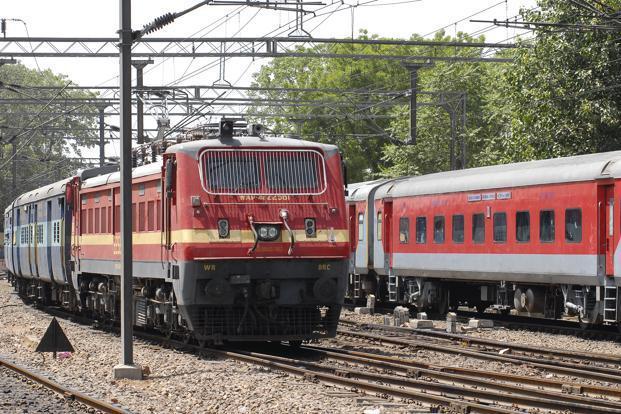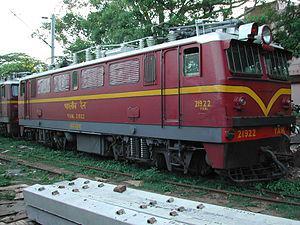The first image is the image on the left, the second image is the image on the right. Given the left and right images, does the statement "There are multiple trains in the image on the left." hold true? Answer yes or no. Yes. The first image is the image on the left, the second image is the image on the right. Considering the images on both sides, is "There are two trains in total traveling in opposite direction." valid? Answer yes or no. No. 